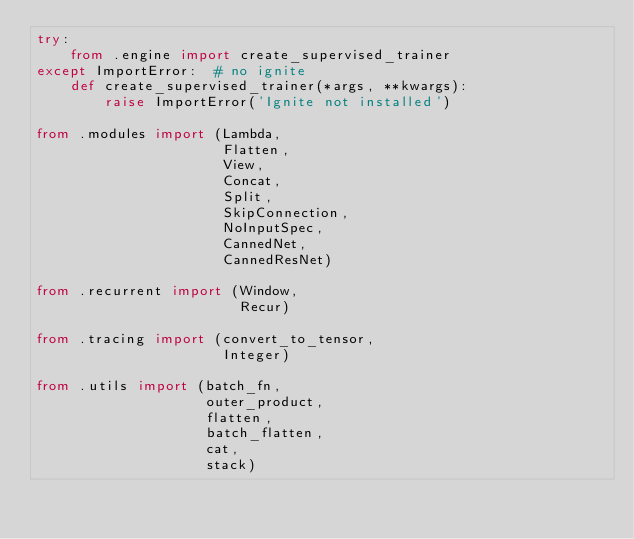Convert code to text. <code><loc_0><loc_0><loc_500><loc_500><_Python_>try:
    from .engine import create_supervised_trainer
except ImportError:  # no ignite
    def create_supervised_trainer(*args, **kwargs):
        raise ImportError('Ignite not installed')

from .modules import (Lambda,
                      Flatten,
                      View,
                      Concat,
                      Split,
                      SkipConnection,
                      NoInputSpec,
                      CannedNet,
                      CannedResNet)

from .recurrent import (Window,
                        Recur)

from .tracing import (convert_to_tensor,
                      Integer)

from .utils import (batch_fn,
                    outer_product,
                    flatten,
                    batch_flatten,
                    cat,
                    stack)
</code> 